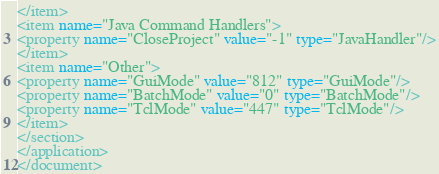Convert code to text. <code><loc_0><loc_0><loc_500><loc_500><_XML_></item>
<item name="Java Command Handlers">
<property name="CloseProject" value="-1" type="JavaHandler"/>
</item>
<item name="Other">
<property name="GuiMode" value="812" type="GuiMode"/>
<property name="BatchMode" value="0" type="BatchMode"/>
<property name="TclMode" value="447" type="TclMode"/>
</item>
</section>
</application>
</document>
</code> 